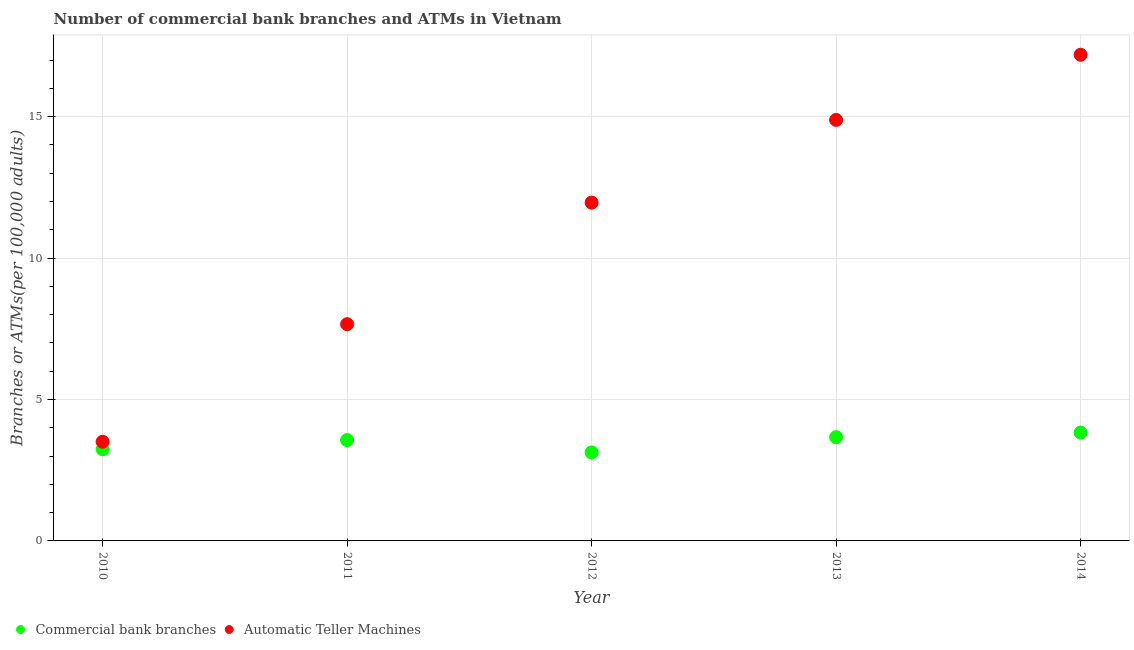Is the number of dotlines equal to the number of legend labels?
Your answer should be very brief. Yes. What is the number of atms in 2014?
Ensure brevity in your answer.  17.19. Across all years, what is the maximum number of commercal bank branches?
Make the answer very short. 3.83. Across all years, what is the minimum number of commercal bank branches?
Keep it short and to the point. 3.13. In which year was the number of commercal bank branches minimum?
Provide a short and direct response. 2012. What is the total number of commercal bank branches in the graph?
Your response must be concise. 17.44. What is the difference between the number of commercal bank branches in 2010 and that in 2012?
Your answer should be very brief. 0.11. What is the difference between the number of commercal bank branches in 2014 and the number of atms in 2012?
Make the answer very short. -8.13. What is the average number of commercal bank branches per year?
Make the answer very short. 3.49. In the year 2010, what is the difference between the number of commercal bank branches and number of atms?
Offer a very short reply. -0.26. What is the ratio of the number of commercal bank branches in 2012 to that in 2013?
Make the answer very short. 0.85. Is the difference between the number of commercal bank branches in 2010 and 2011 greater than the difference between the number of atms in 2010 and 2011?
Your answer should be very brief. Yes. What is the difference between the highest and the second highest number of atms?
Provide a succinct answer. 2.3. What is the difference between the highest and the lowest number of commercal bank branches?
Ensure brevity in your answer.  0.7. In how many years, is the number of commercal bank branches greater than the average number of commercal bank branches taken over all years?
Your response must be concise. 3. Is the sum of the number of commercal bank branches in 2010 and 2012 greater than the maximum number of atms across all years?
Ensure brevity in your answer.  No. Does the number of atms monotonically increase over the years?
Provide a short and direct response. Yes. Is the number of atms strictly greater than the number of commercal bank branches over the years?
Offer a terse response. Yes. Is the number of atms strictly less than the number of commercal bank branches over the years?
Provide a succinct answer. No. Are the values on the major ticks of Y-axis written in scientific E-notation?
Your answer should be compact. No. Does the graph contain any zero values?
Offer a terse response. No. Where does the legend appear in the graph?
Keep it short and to the point. Bottom left. How are the legend labels stacked?
Make the answer very short. Horizontal. What is the title of the graph?
Give a very brief answer. Number of commercial bank branches and ATMs in Vietnam. What is the label or title of the X-axis?
Make the answer very short. Year. What is the label or title of the Y-axis?
Give a very brief answer. Branches or ATMs(per 100,0 adults). What is the Branches or ATMs(per 100,000 adults) of Commercial bank branches in 2010?
Make the answer very short. 3.24. What is the Branches or ATMs(per 100,000 adults) in Automatic Teller Machines in 2010?
Ensure brevity in your answer.  3.51. What is the Branches or ATMs(per 100,000 adults) in Commercial bank branches in 2011?
Keep it short and to the point. 3.57. What is the Branches or ATMs(per 100,000 adults) in Automatic Teller Machines in 2011?
Keep it short and to the point. 7.66. What is the Branches or ATMs(per 100,000 adults) of Commercial bank branches in 2012?
Your response must be concise. 3.13. What is the Branches or ATMs(per 100,000 adults) in Automatic Teller Machines in 2012?
Offer a terse response. 11.96. What is the Branches or ATMs(per 100,000 adults) of Commercial bank branches in 2013?
Ensure brevity in your answer.  3.67. What is the Branches or ATMs(per 100,000 adults) in Automatic Teller Machines in 2013?
Make the answer very short. 14.89. What is the Branches or ATMs(per 100,000 adults) of Commercial bank branches in 2014?
Keep it short and to the point. 3.83. What is the Branches or ATMs(per 100,000 adults) of Automatic Teller Machines in 2014?
Provide a succinct answer. 17.19. Across all years, what is the maximum Branches or ATMs(per 100,000 adults) of Commercial bank branches?
Make the answer very short. 3.83. Across all years, what is the maximum Branches or ATMs(per 100,000 adults) in Automatic Teller Machines?
Offer a terse response. 17.19. Across all years, what is the minimum Branches or ATMs(per 100,000 adults) in Commercial bank branches?
Offer a terse response. 3.13. Across all years, what is the minimum Branches or ATMs(per 100,000 adults) in Automatic Teller Machines?
Keep it short and to the point. 3.51. What is the total Branches or ATMs(per 100,000 adults) in Commercial bank branches in the graph?
Your answer should be compact. 17.44. What is the total Branches or ATMs(per 100,000 adults) of Automatic Teller Machines in the graph?
Offer a terse response. 55.21. What is the difference between the Branches or ATMs(per 100,000 adults) of Commercial bank branches in 2010 and that in 2011?
Your answer should be very brief. -0.32. What is the difference between the Branches or ATMs(per 100,000 adults) in Automatic Teller Machines in 2010 and that in 2011?
Provide a succinct answer. -4.16. What is the difference between the Branches or ATMs(per 100,000 adults) of Commercial bank branches in 2010 and that in 2012?
Offer a very short reply. 0.11. What is the difference between the Branches or ATMs(per 100,000 adults) of Automatic Teller Machines in 2010 and that in 2012?
Your answer should be very brief. -8.46. What is the difference between the Branches or ATMs(per 100,000 adults) in Commercial bank branches in 2010 and that in 2013?
Your response must be concise. -0.42. What is the difference between the Branches or ATMs(per 100,000 adults) of Automatic Teller Machines in 2010 and that in 2013?
Your response must be concise. -11.38. What is the difference between the Branches or ATMs(per 100,000 adults) of Commercial bank branches in 2010 and that in 2014?
Your answer should be very brief. -0.59. What is the difference between the Branches or ATMs(per 100,000 adults) of Automatic Teller Machines in 2010 and that in 2014?
Keep it short and to the point. -13.68. What is the difference between the Branches or ATMs(per 100,000 adults) of Commercial bank branches in 2011 and that in 2012?
Your answer should be compact. 0.44. What is the difference between the Branches or ATMs(per 100,000 adults) in Automatic Teller Machines in 2011 and that in 2012?
Ensure brevity in your answer.  -4.3. What is the difference between the Branches or ATMs(per 100,000 adults) in Commercial bank branches in 2011 and that in 2013?
Make the answer very short. -0.1. What is the difference between the Branches or ATMs(per 100,000 adults) of Automatic Teller Machines in 2011 and that in 2013?
Your answer should be very brief. -7.22. What is the difference between the Branches or ATMs(per 100,000 adults) in Commercial bank branches in 2011 and that in 2014?
Provide a short and direct response. -0.26. What is the difference between the Branches or ATMs(per 100,000 adults) of Automatic Teller Machines in 2011 and that in 2014?
Provide a short and direct response. -9.53. What is the difference between the Branches or ATMs(per 100,000 adults) of Commercial bank branches in 2012 and that in 2013?
Provide a succinct answer. -0.54. What is the difference between the Branches or ATMs(per 100,000 adults) in Automatic Teller Machines in 2012 and that in 2013?
Offer a terse response. -2.92. What is the difference between the Branches or ATMs(per 100,000 adults) of Commercial bank branches in 2012 and that in 2014?
Provide a short and direct response. -0.7. What is the difference between the Branches or ATMs(per 100,000 adults) of Automatic Teller Machines in 2012 and that in 2014?
Offer a very short reply. -5.23. What is the difference between the Branches or ATMs(per 100,000 adults) in Commercial bank branches in 2013 and that in 2014?
Provide a succinct answer. -0.16. What is the difference between the Branches or ATMs(per 100,000 adults) in Automatic Teller Machines in 2013 and that in 2014?
Make the answer very short. -2.3. What is the difference between the Branches or ATMs(per 100,000 adults) in Commercial bank branches in 2010 and the Branches or ATMs(per 100,000 adults) in Automatic Teller Machines in 2011?
Give a very brief answer. -4.42. What is the difference between the Branches or ATMs(per 100,000 adults) in Commercial bank branches in 2010 and the Branches or ATMs(per 100,000 adults) in Automatic Teller Machines in 2012?
Your answer should be compact. -8.72. What is the difference between the Branches or ATMs(per 100,000 adults) of Commercial bank branches in 2010 and the Branches or ATMs(per 100,000 adults) of Automatic Teller Machines in 2013?
Ensure brevity in your answer.  -11.64. What is the difference between the Branches or ATMs(per 100,000 adults) in Commercial bank branches in 2010 and the Branches or ATMs(per 100,000 adults) in Automatic Teller Machines in 2014?
Your response must be concise. -13.95. What is the difference between the Branches or ATMs(per 100,000 adults) of Commercial bank branches in 2011 and the Branches or ATMs(per 100,000 adults) of Automatic Teller Machines in 2012?
Your answer should be compact. -8.39. What is the difference between the Branches or ATMs(per 100,000 adults) of Commercial bank branches in 2011 and the Branches or ATMs(per 100,000 adults) of Automatic Teller Machines in 2013?
Make the answer very short. -11.32. What is the difference between the Branches or ATMs(per 100,000 adults) of Commercial bank branches in 2011 and the Branches or ATMs(per 100,000 adults) of Automatic Teller Machines in 2014?
Keep it short and to the point. -13.62. What is the difference between the Branches or ATMs(per 100,000 adults) of Commercial bank branches in 2012 and the Branches or ATMs(per 100,000 adults) of Automatic Teller Machines in 2013?
Give a very brief answer. -11.76. What is the difference between the Branches or ATMs(per 100,000 adults) of Commercial bank branches in 2012 and the Branches or ATMs(per 100,000 adults) of Automatic Teller Machines in 2014?
Provide a short and direct response. -14.06. What is the difference between the Branches or ATMs(per 100,000 adults) of Commercial bank branches in 2013 and the Branches or ATMs(per 100,000 adults) of Automatic Teller Machines in 2014?
Offer a terse response. -13.52. What is the average Branches or ATMs(per 100,000 adults) in Commercial bank branches per year?
Ensure brevity in your answer.  3.49. What is the average Branches or ATMs(per 100,000 adults) of Automatic Teller Machines per year?
Offer a very short reply. 11.04. In the year 2010, what is the difference between the Branches or ATMs(per 100,000 adults) of Commercial bank branches and Branches or ATMs(per 100,000 adults) of Automatic Teller Machines?
Ensure brevity in your answer.  -0.26. In the year 2011, what is the difference between the Branches or ATMs(per 100,000 adults) in Commercial bank branches and Branches or ATMs(per 100,000 adults) in Automatic Teller Machines?
Provide a short and direct response. -4.1. In the year 2012, what is the difference between the Branches or ATMs(per 100,000 adults) in Commercial bank branches and Branches or ATMs(per 100,000 adults) in Automatic Teller Machines?
Your answer should be very brief. -8.83. In the year 2013, what is the difference between the Branches or ATMs(per 100,000 adults) in Commercial bank branches and Branches or ATMs(per 100,000 adults) in Automatic Teller Machines?
Provide a succinct answer. -11.22. In the year 2014, what is the difference between the Branches or ATMs(per 100,000 adults) of Commercial bank branches and Branches or ATMs(per 100,000 adults) of Automatic Teller Machines?
Keep it short and to the point. -13.36. What is the ratio of the Branches or ATMs(per 100,000 adults) of Commercial bank branches in 2010 to that in 2011?
Your answer should be very brief. 0.91. What is the ratio of the Branches or ATMs(per 100,000 adults) in Automatic Teller Machines in 2010 to that in 2011?
Your response must be concise. 0.46. What is the ratio of the Branches or ATMs(per 100,000 adults) of Commercial bank branches in 2010 to that in 2012?
Ensure brevity in your answer.  1.04. What is the ratio of the Branches or ATMs(per 100,000 adults) of Automatic Teller Machines in 2010 to that in 2012?
Offer a terse response. 0.29. What is the ratio of the Branches or ATMs(per 100,000 adults) in Commercial bank branches in 2010 to that in 2013?
Your answer should be compact. 0.88. What is the ratio of the Branches or ATMs(per 100,000 adults) of Automatic Teller Machines in 2010 to that in 2013?
Offer a very short reply. 0.24. What is the ratio of the Branches or ATMs(per 100,000 adults) of Commercial bank branches in 2010 to that in 2014?
Provide a short and direct response. 0.85. What is the ratio of the Branches or ATMs(per 100,000 adults) of Automatic Teller Machines in 2010 to that in 2014?
Ensure brevity in your answer.  0.2. What is the ratio of the Branches or ATMs(per 100,000 adults) in Commercial bank branches in 2011 to that in 2012?
Your answer should be very brief. 1.14. What is the ratio of the Branches or ATMs(per 100,000 adults) of Automatic Teller Machines in 2011 to that in 2012?
Give a very brief answer. 0.64. What is the ratio of the Branches or ATMs(per 100,000 adults) in Commercial bank branches in 2011 to that in 2013?
Offer a terse response. 0.97. What is the ratio of the Branches or ATMs(per 100,000 adults) in Automatic Teller Machines in 2011 to that in 2013?
Your answer should be compact. 0.51. What is the ratio of the Branches or ATMs(per 100,000 adults) in Commercial bank branches in 2011 to that in 2014?
Give a very brief answer. 0.93. What is the ratio of the Branches or ATMs(per 100,000 adults) in Automatic Teller Machines in 2011 to that in 2014?
Provide a short and direct response. 0.45. What is the ratio of the Branches or ATMs(per 100,000 adults) in Commercial bank branches in 2012 to that in 2013?
Keep it short and to the point. 0.85. What is the ratio of the Branches or ATMs(per 100,000 adults) of Automatic Teller Machines in 2012 to that in 2013?
Provide a succinct answer. 0.8. What is the ratio of the Branches or ATMs(per 100,000 adults) in Commercial bank branches in 2012 to that in 2014?
Ensure brevity in your answer.  0.82. What is the ratio of the Branches or ATMs(per 100,000 adults) of Automatic Teller Machines in 2012 to that in 2014?
Your answer should be compact. 0.7. What is the ratio of the Branches or ATMs(per 100,000 adults) of Commercial bank branches in 2013 to that in 2014?
Give a very brief answer. 0.96. What is the ratio of the Branches or ATMs(per 100,000 adults) of Automatic Teller Machines in 2013 to that in 2014?
Offer a very short reply. 0.87. What is the difference between the highest and the second highest Branches or ATMs(per 100,000 adults) of Commercial bank branches?
Give a very brief answer. 0.16. What is the difference between the highest and the second highest Branches or ATMs(per 100,000 adults) of Automatic Teller Machines?
Your answer should be compact. 2.3. What is the difference between the highest and the lowest Branches or ATMs(per 100,000 adults) of Commercial bank branches?
Make the answer very short. 0.7. What is the difference between the highest and the lowest Branches or ATMs(per 100,000 adults) of Automatic Teller Machines?
Offer a terse response. 13.68. 